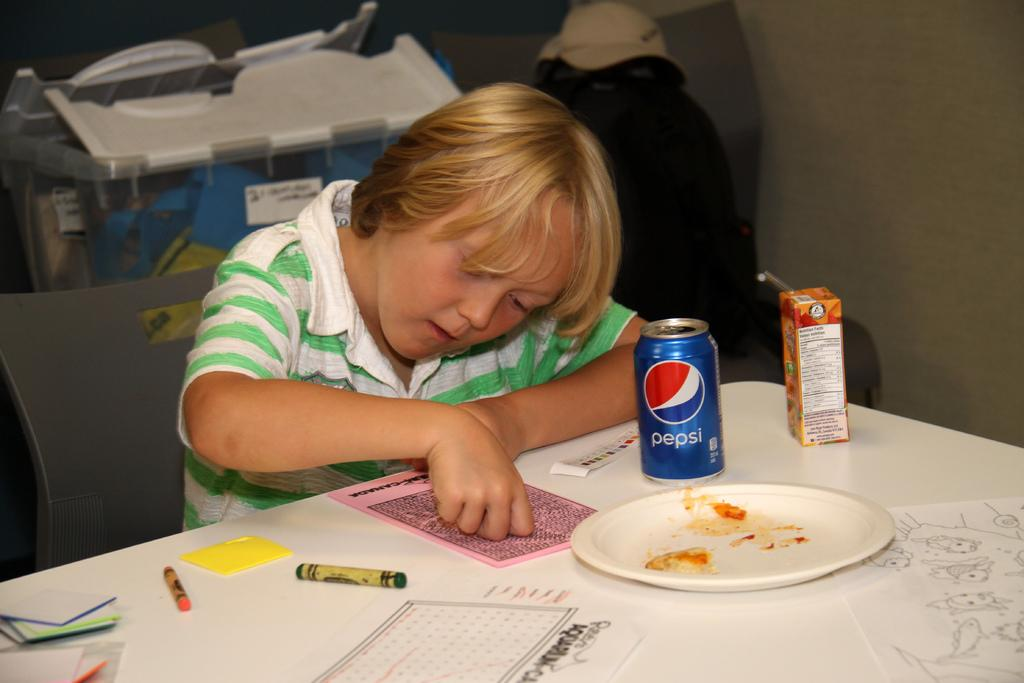Provide a one-sentence caption for the provided image. A blue can of Pepsi is on a table, next to a kid. 